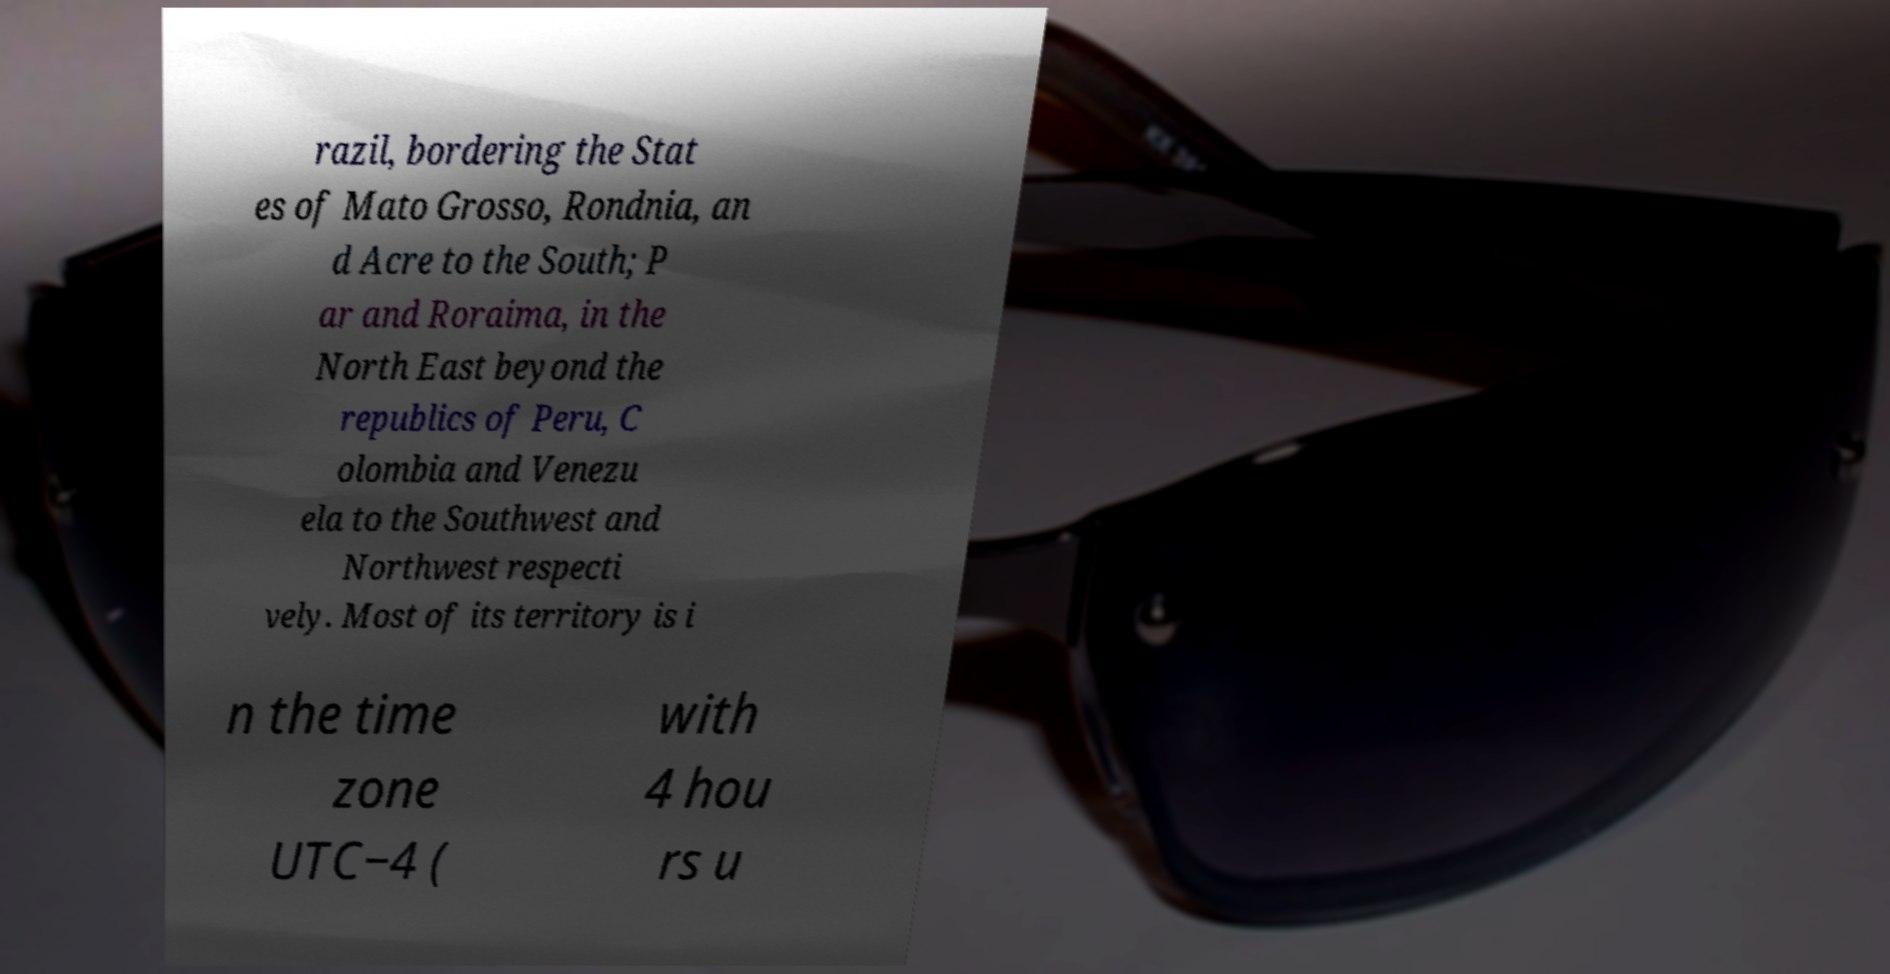Can you accurately transcribe the text from the provided image for me? razil, bordering the Stat es of Mato Grosso, Rondnia, an d Acre to the South; P ar and Roraima, in the North East beyond the republics of Peru, C olombia and Venezu ela to the Southwest and Northwest respecti vely. Most of its territory is i n the time zone UTC−4 ( with 4 hou rs u 